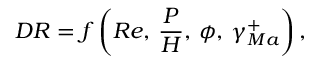<formula> <loc_0><loc_0><loc_500><loc_500>{ D R } = f \left ( { R e } , \, \frac { P } { H } , \, \phi , \, \gamma _ { M a } ^ { + } \right ) ,</formula> 